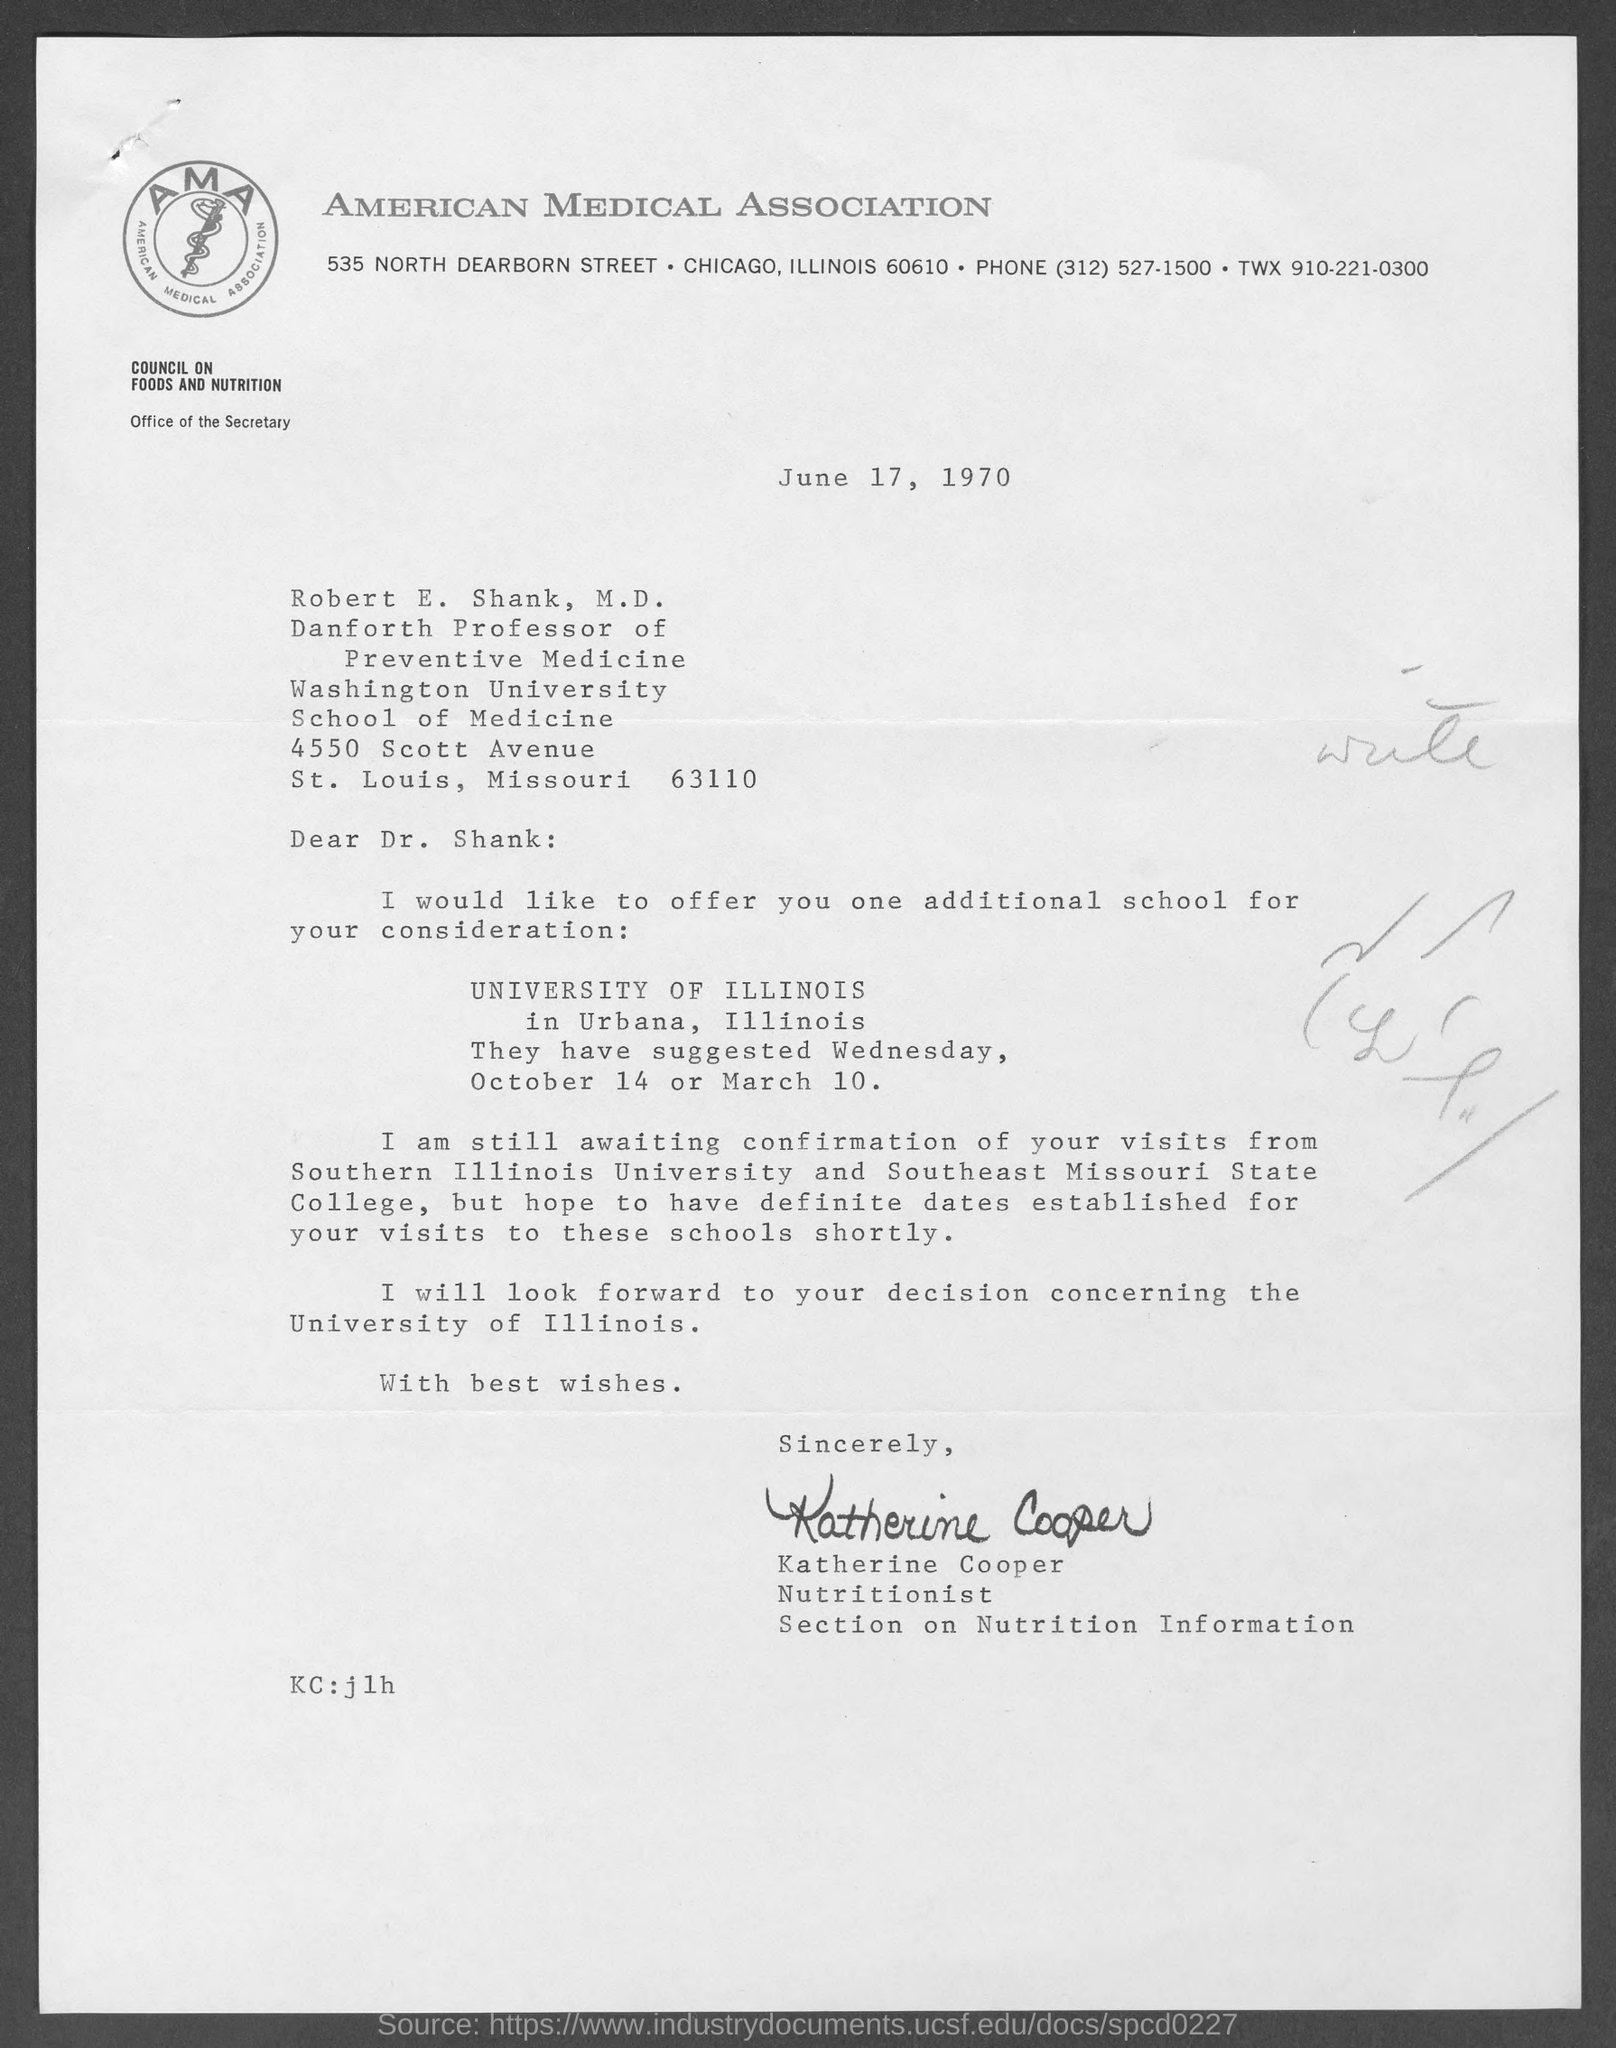Which association is mentioned in the letterhead?
Your answer should be very brief. American Medical Association. Who is the sender of this letter?
Give a very brief answer. Katherine Cooper. What is the date mentioned in this letter?
Keep it short and to the point. June 17, 1970. What is the designation of Robert E. Shank, M.D.?
Keep it short and to the point. Danforth Professor of Preventive Medicine. 